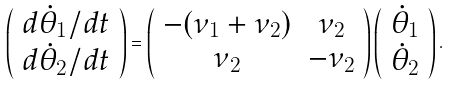<formula> <loc_0><loc_0><loc_500><loc_500>\left ( \begin{array} { c } d \dot { \theta } _ { 1 } / d t \\ d \dot { \theta } _ { 2 } / d t \\ \end{array} \right ) = \left ( \begin{array} { c c } - ( \nu _ { 1 } + \nu _ { 2 } ) & \nu _ { 2 } \\ \nu _ { 2 } & - \nu _ { 2 } \\ \end{array} \right ) \left ( \begin{array} { c } \dot { \theta } _ { 1 } \\ \dot { \theta } _ { 2 } \\ \end{array} \right ) .</formula> 